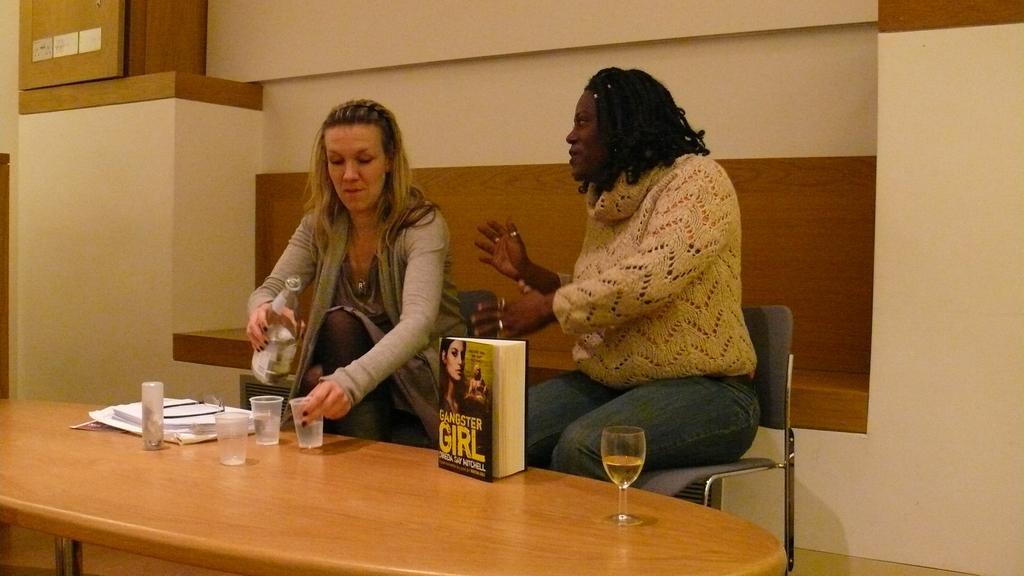Describe this image in one or two sentences. In this picture we can see two persons sitting on the chairs. This is table. On the table there are glasses, book, and papers. She is holding a bottle with her hand. On the background there is a wall. 